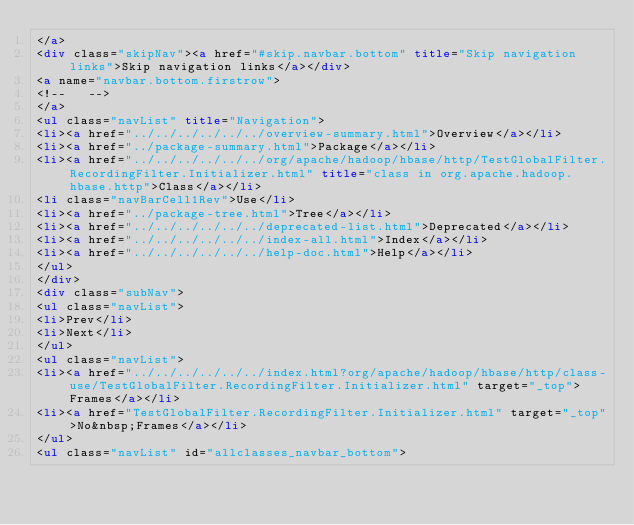Convert code to text. <code><loc_0><loc_0><loc_500><loc_500><_HTML_></a>
<div class="skipNav"><a href="#skip.navbar.bottom" title="Skip navigation links">Skip navigation links</a></div>
<a name="navbar.bottom.firstrow">
<!--   -->
</a>
<ul class="navList" title="Navigation">
<li><a href="../../../../../../overview-summary.html">Overview</a></li>
<li><a href="../package-summary.html">Package</a></li>
<li><a href="../../../../../../org/apache/hadoop/hbase/http/TestGlobalFilter.RecordingFilter.Initializer.html" title="class in org.apache.hadoop.hbase.http">Class</a></li>
<li class="navBarCell1Rev">Use</li>
<li><a href="../package-tree.html">Tree</a></li>
<li><a href="../../../../../../deprecated-list.html">Deprecated</a></li>
<li><a href="../../../../../../index-all.html">Index</a></li>
<li><a href="../../../../../../help-doc.html">Help</a></li>
</ul>
</div>
<div class="subNav">
<ul class="navList">
<li>Prev</li>
<li>Next</li>
</ul>
<ul class="navList">
<li><a href="../../../../../../index.html?org/apache/hadoop/hbase/http/class-use/TestGlobalFilter.RecordingFilter.Initializer.html" target="_top">Frames</a></li>
<li><a href="TestGlobalFilter.RecordingFilter.Initializer.html" target="_top">No&nbsp;Frames</a></li>
</ul>
<ul class="navList" id="allclasses_navbar_bottom"></code> 